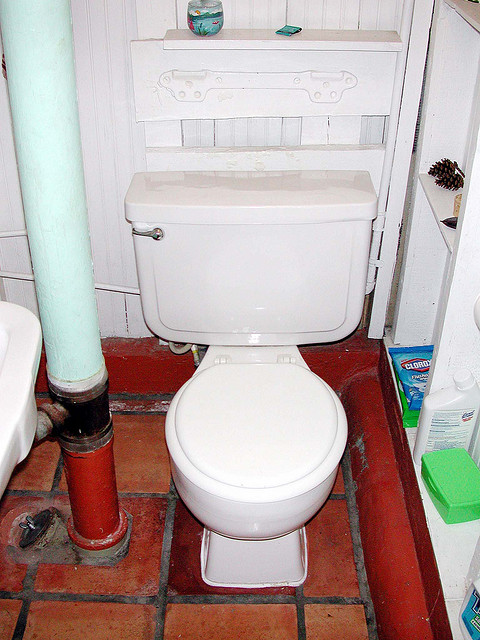Identify and read out the text in this image. CLORO 